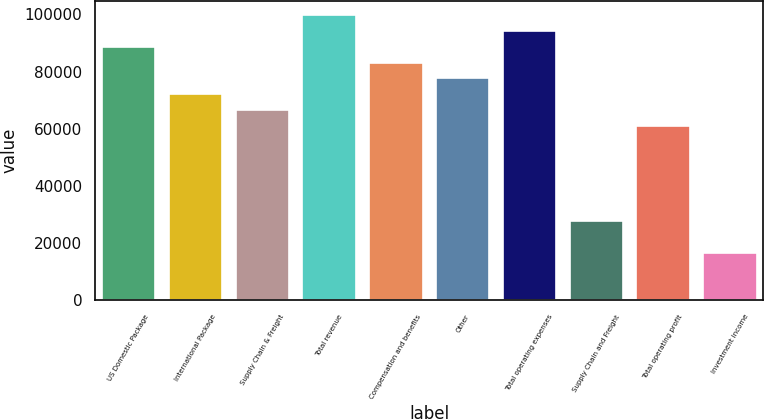<chart> <loc_0><loc_0><loc_500><loc_500><bar_chart><fcel>US Domestic Package<fcel>International Package<fcel>Supply Chain & Freight<fcel>Total revenue<fcel>Compensation and benefits<fcel>Other<fcel>Total operating expenses<fcel>Supply Chain and Freight<fcel>Total operating profit<fcel>Investment income<nl><fcel>88699.3<fcel>72068.6<fcel>66525.1<fcel>99786.4<fcel>83155.7<fcel>77612.2<fcel>94242.8<fcel>27720.2<fcel>60981.5<fcel>16633.1<nl></chart> 